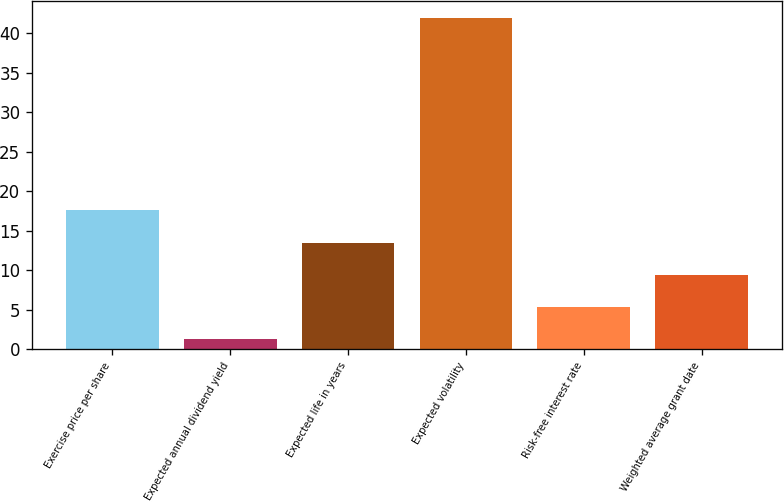<chart> <loc_0><loc_0><loc_500><loc_500><bar_chart><fcel>Exercise price per share<fcel>Expected annual dividend yield<fcel>Expected life in years<fcel>Expected volatility<fcel>Risk-free interest rate<fcel>Weighted average grant date<nl><fcel>17.58<fcel>1.3<fcel>13.51<fcel>42<fcel>5.37<fcel>9.44<nl></chart> 